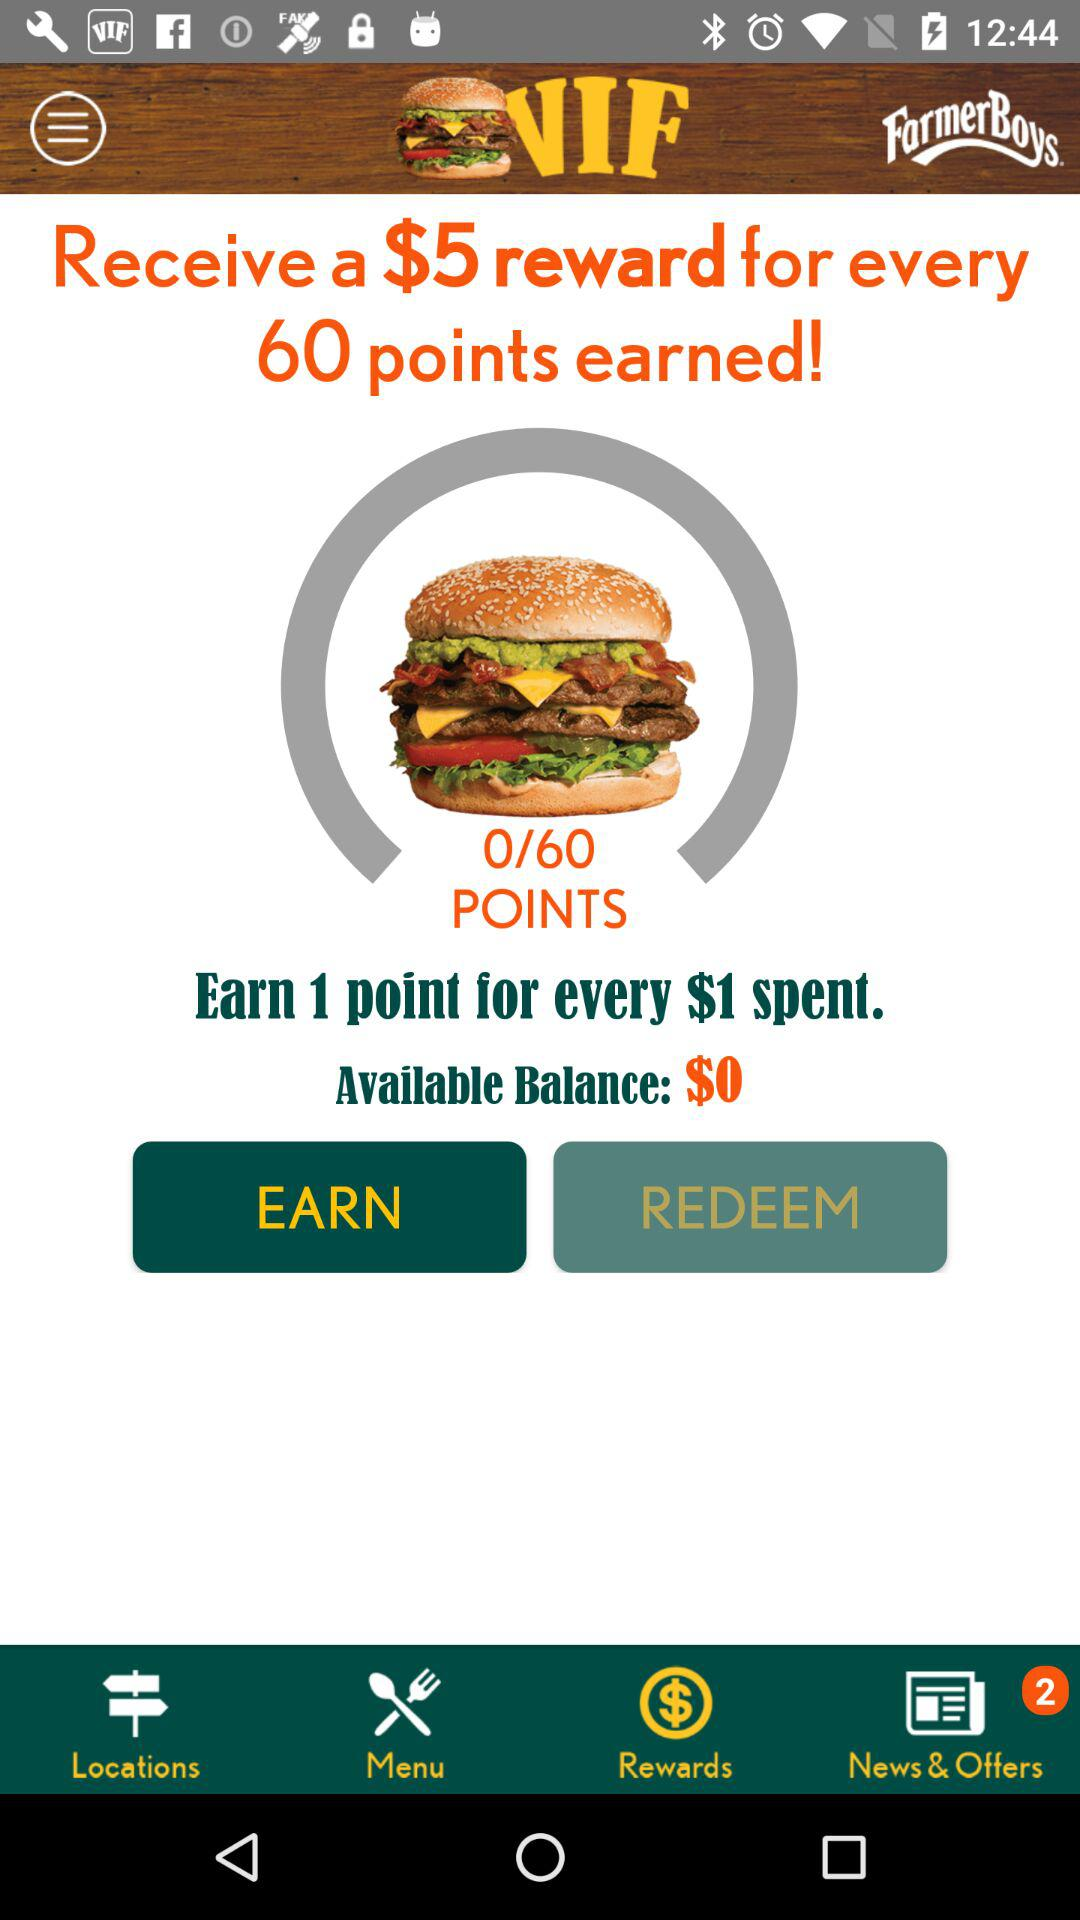How much money is spent when we earn 1 point?
Answer the question using a single word or phrase. You spent $1. 